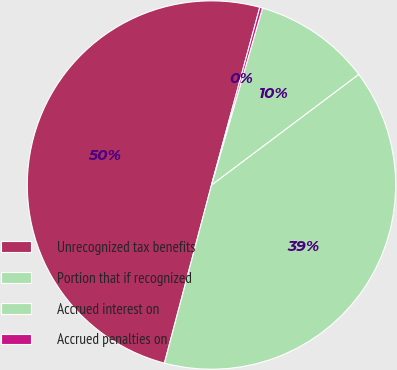Convert chart. <chart><loc_0><loc_0><loc_500><loc_500><pie_chart><fcel>Unrecognized tax benefits<fcel>Portion that if recognized<fcel>Accrued interest on<fcel>Accrued penalties on<nl><fcel>50.11%<fcel>39.37%<fcel>10.27%<fcel>0.24%<nl></chart> 